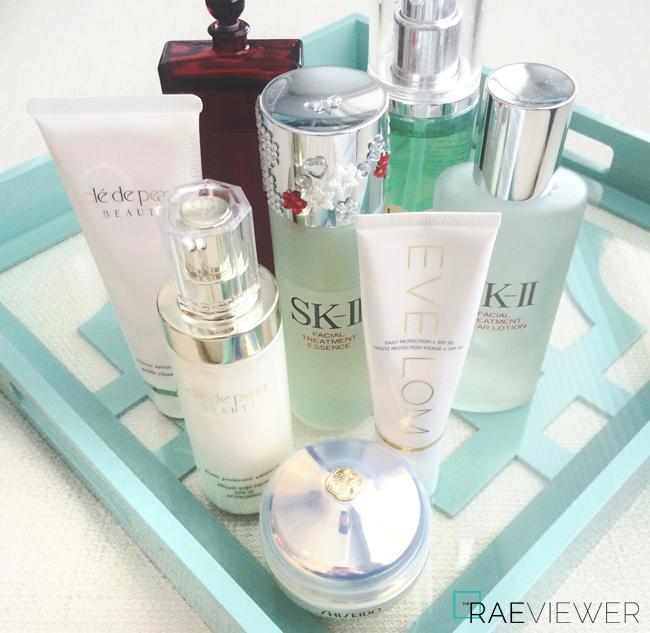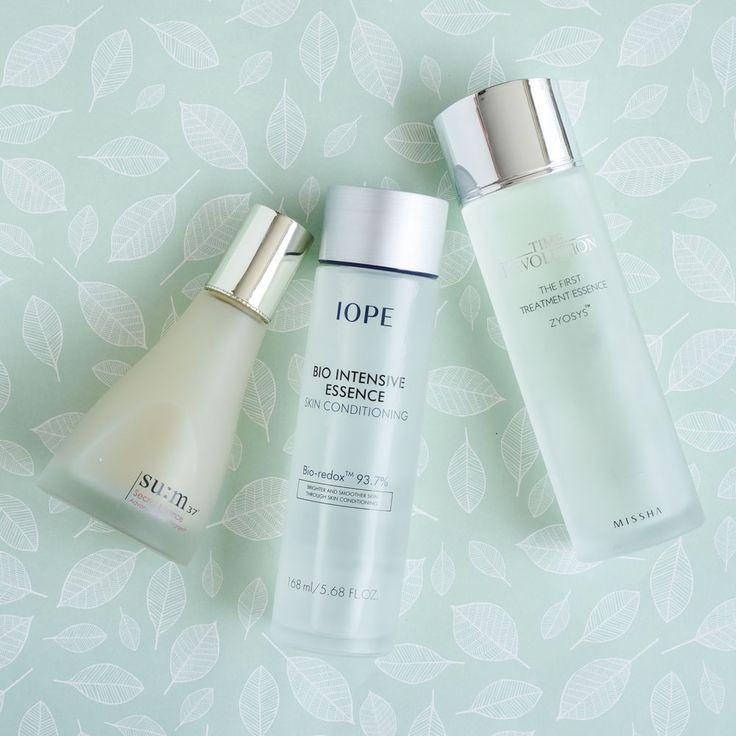The first image is the image on the left, the second image is the image on the right. For the images displayed, is the sentence "IN at least one image there is at least one lipstick lying on it's side and one chapstick in a round container." factually correct? Answer yes or no. No. The first image is the image on the left, the second image is the image on the right. Analyze the images presented: Is the assertion "One image shows no more than three items, which are laid flat on a surface, and the other image includes multiple products displayed standing upright." valid? Answer yes or no. Yes. 